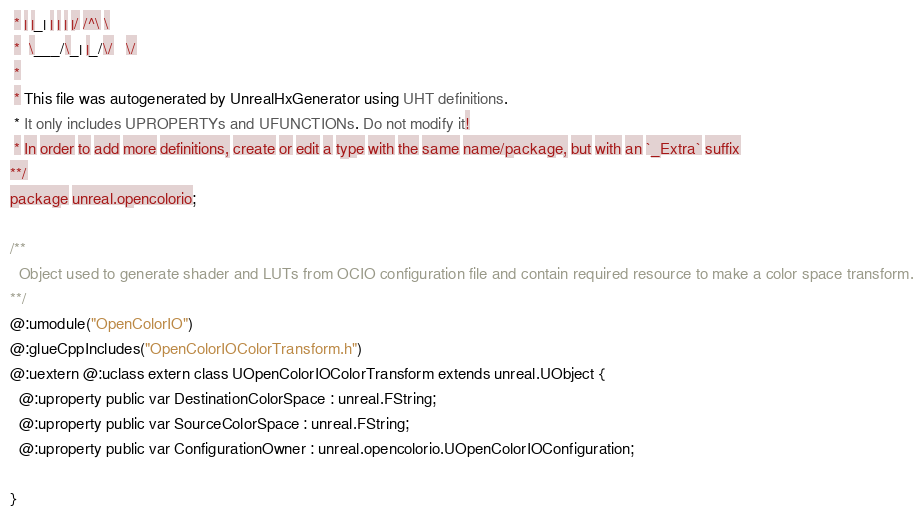Convert code to text. <code><loc_0><loc_0><loc_500><loc_500><_Haxe_> * | |_| | | | |/ /^\ \ 
 *  \___/\_| |_/\/   \/ 
 * 
 * This file was autogenerated by UnrealHxGenerator using UHT definitions.
 * It only includes UPROPERTYs and UFUNCTIONs. Do not modify it!
 * In order to add more definitions, create or edit a type with the same name/package, but with an `_Extra` suffix
**/
package unreal.opencolorio;

/**
  Object used to generate shader and LUTs from OCIO configuration file and contain required resource to make a color space transform.
**/
@:umodule("OpenColorIO")
@:glueCppIncludes("OpenColorIOColorTransform.h")
@:uextern @:uclass extern class UOpenColorIOColorTransform extends unreal.UObject {
  @:uproperty public var DestinationColorSpace : unreal.FString;
  @:uproperty public var SourceColorSpace : unreal.FString;
  @:uproperty public var ConfigurationOwner : unreal.opencolorio.UOpenColorIOConfiguration;
  
}
</code> 